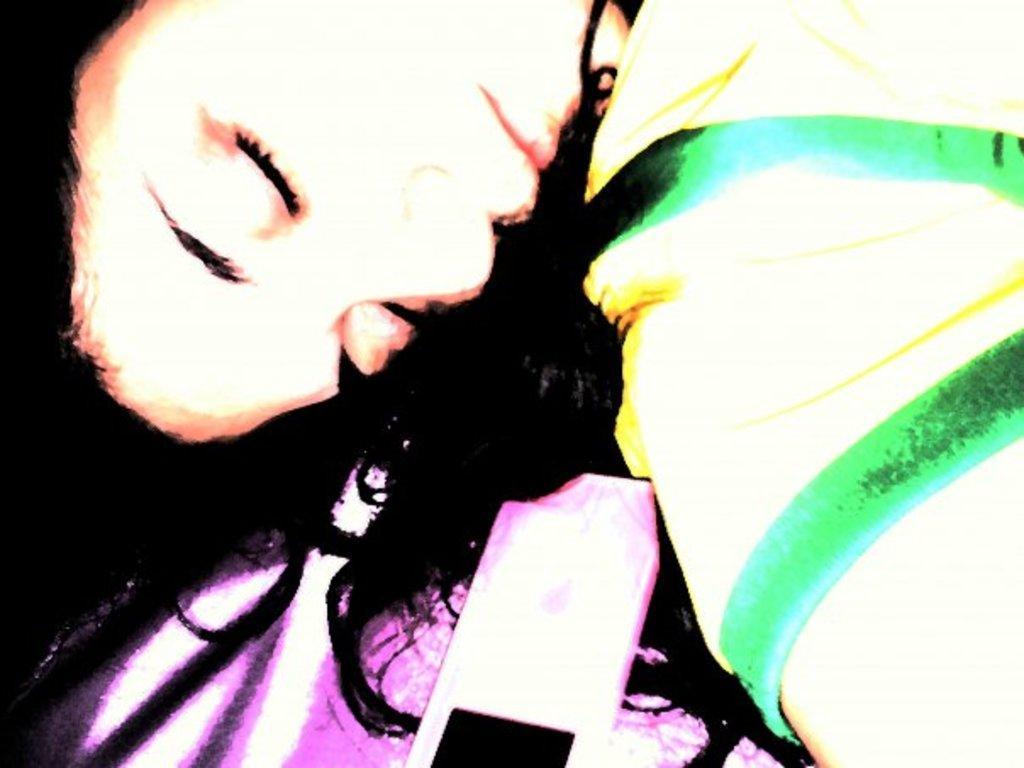Could you give a brief overview of what you see in this image? In this image we can see a person and mobile. 